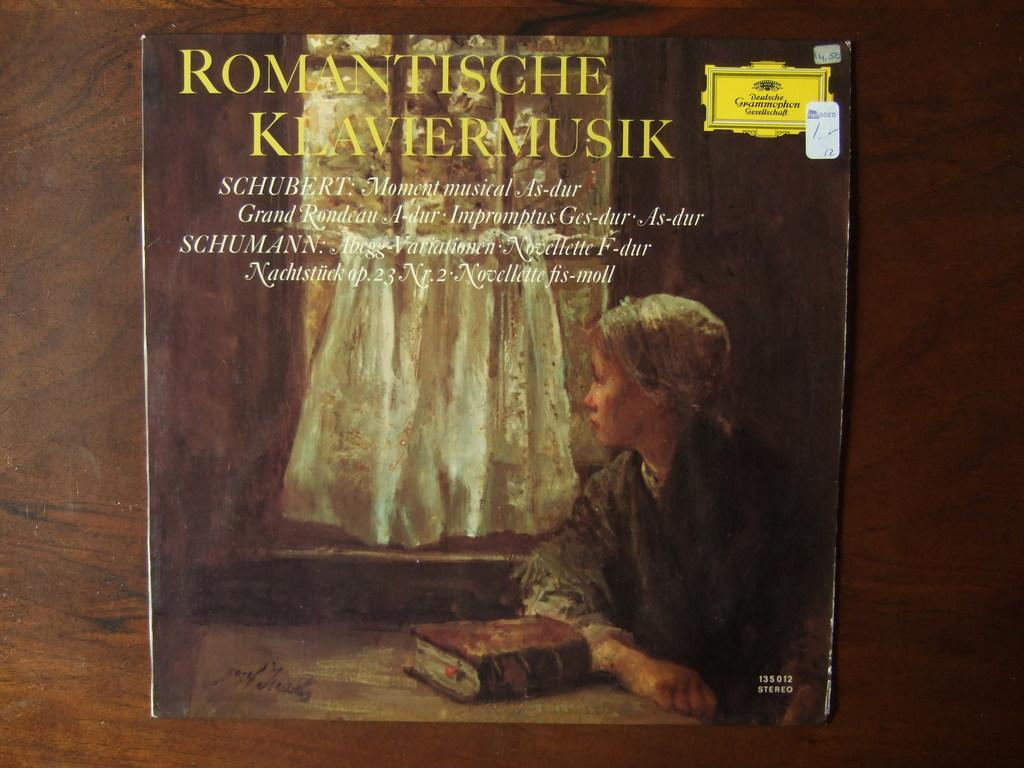Provide a one-sentence caption for the provided image. A woman looks out the window on the cover of this Romantische Klaviermusik album. 